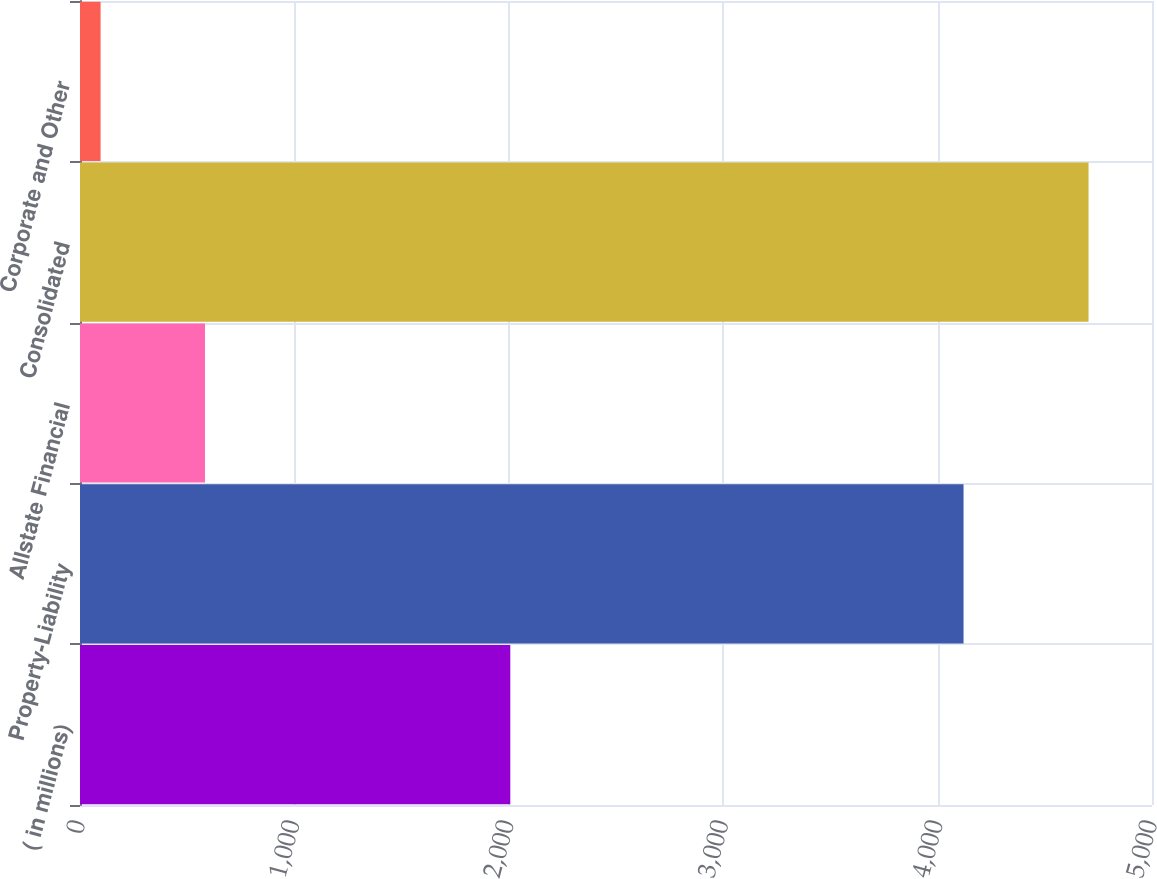Convert chart. <chart><loc_0><loc_0><loc_500><loc_500><bar_chart><fcel>( in millions)<fcel>Property-Liability<fcel>Allstate Financial<fcel>Consolidated<fcel>Corporate and Other<nl><fcel>2007<fcel>4121<fcel>583<fcel>4704<fcel>96<nl></chart> 